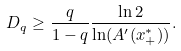Convert formula to latex. <formula><loc_0><loc_0><loc_500><loc_500>D _ { q } \geq \frac { q } { 1 - q } \frac { \ln 2 } { \ln ( A ^ { \prime } ( x ^ { * } _ { + } ) ) } .</formula> 